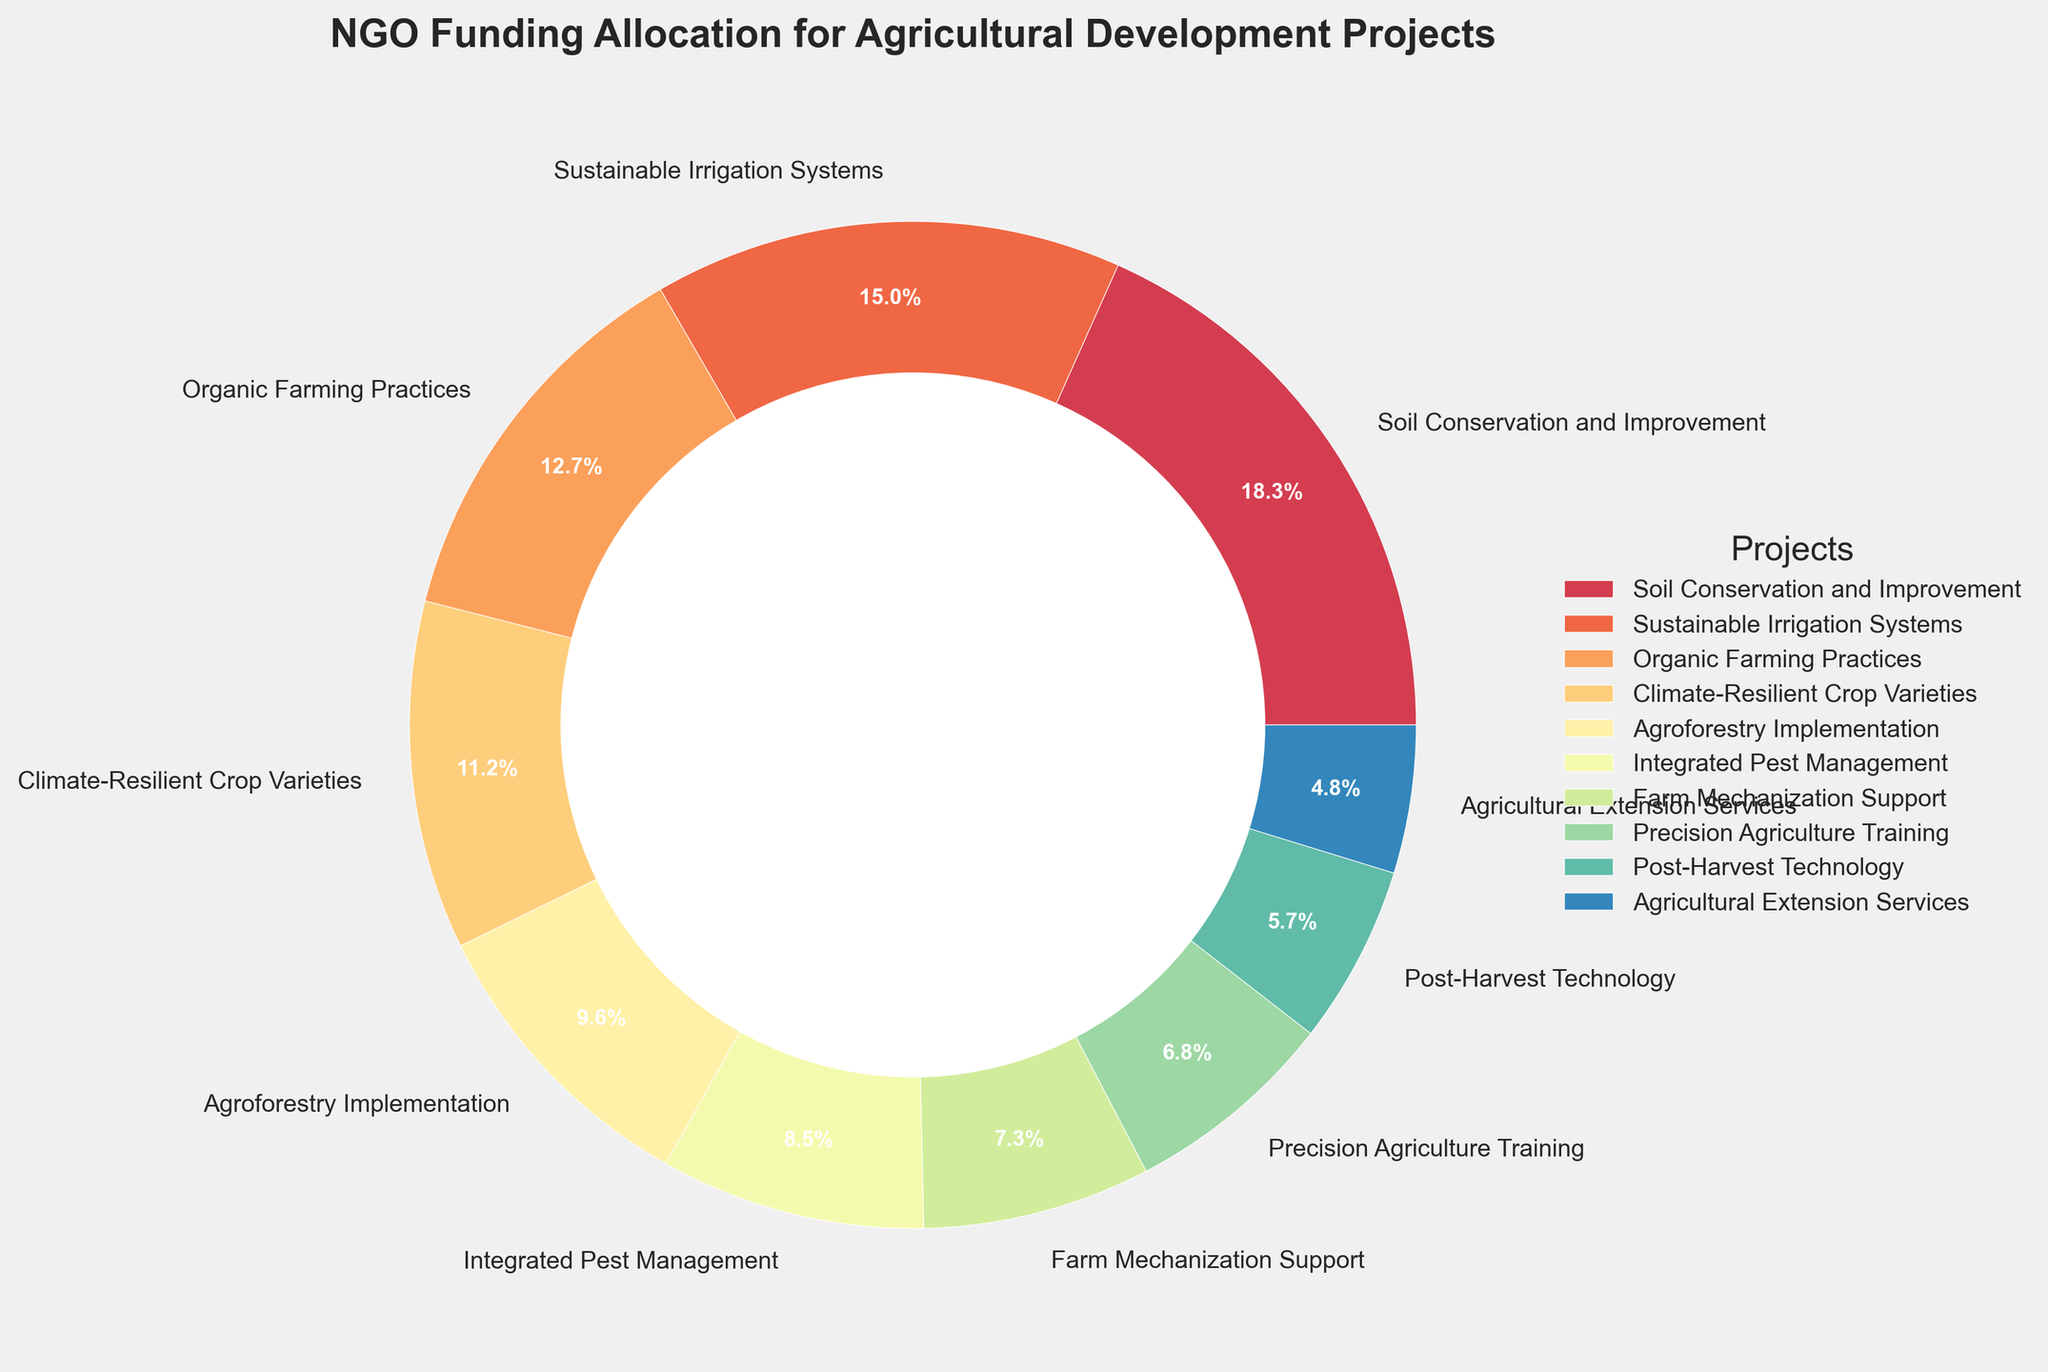What's the total percentage of funding allocated to Organic Farming Practices, Integrated Pest Management, and Precision Agriculture Training? The funding percentages for these projects are 12.8%, 8.6%, and 6.9%, respectively. Summing these values: 12.8 + 8.6 + 6.9 = 28.3
Answer: 28.3% Which project receives the highest funding percentage? From the pie chart, the project with the largest segment and highest percentage is Soil Conservation and Improvement at 18.5%
Answer: Soil Conservation and Improvement Which project has a lower funding percentage: Farm Mechanization Support or Post-Harvest Technology? By comparing the segments of Farm Mechanization Support (7.4%) and Post-Harvest Technology (5.8%), the latter has a lower percentage
Answer: Post-Harvest Technology Is the funding for Climate-Resilient Crop Varieties greater than the combined funding for Agricultural Extension Services and Agroforestry Implementation? The funding for Climate-Resilient Crop Varieties is 11.3%. Combined funding for Agricultural Extension Services (4.8%) and Agroforestry Implementation (9.7%) is 4.8 + 9.7 = 14.5%. 14.5 is greater than 11.3
Answer: No What is the color of the project with the least funding percentage? The project with the least funding percentage is Agricultural Extension Services at 4.8%. Observing the chart, its segment is shaded in one of the lightest tones of the color spectrum used in the pie chart
Answer: Light tone How many projects have a funding percentage greater than 10%? By inspecting the pie chart, the projects with funding percentages greater than 10% are Soil Conservation and Improvement (18.5%), Sustainable Irrigation Systems (15.2%), and Climate-Resilient Crop Varieties (11.3%)
Answer: 3 What is the sum of the funding percentages for the three projects with the smallest allocations? The three projects with the smallest funding percentages are Agricultural Extension Services (4.8%), Post-Harvest Technology (5.8%), and Precision Agriculture Training (6.9%). Summing these: 4.8 + 5.8 + 6.9 = 17.5
Answer: 17.5% Which is larger, the funding for Sustainable Irrigation Systems or the combined funding for Climate-Resilient Crop Varieties and Farm Mechanization Support? Sustainable Irrigation Systems have 15.2%. Combined funding for Climate-Resilient Crop Varieties (11.3%) and Farm Mechanization Support (7.4%) is 11.3 + 7.4 = 18.7. 18.7 is larger than 15.2
Answer: Combined funding How many projects receive more than 8% but less than 10% of the funding? By reviewing the segments on the pie chart, Agroforestry Implementation (9.7%) and Integrated Pest Management (8.6%) fall within this range
Answer: 2 Which two projects combined have an allocation closest to 20%? By adding different project percentages, the two closest come from Integrated Pest Management (8.6%) and Farm Mechanization Support (7.4%) totaling 8.6 + 7.4 = 16.0, and Precision Agriculture Training (6.9%) making it closer to 20%
Answer: Integrated Pest Management and Farm Mechanization Support 